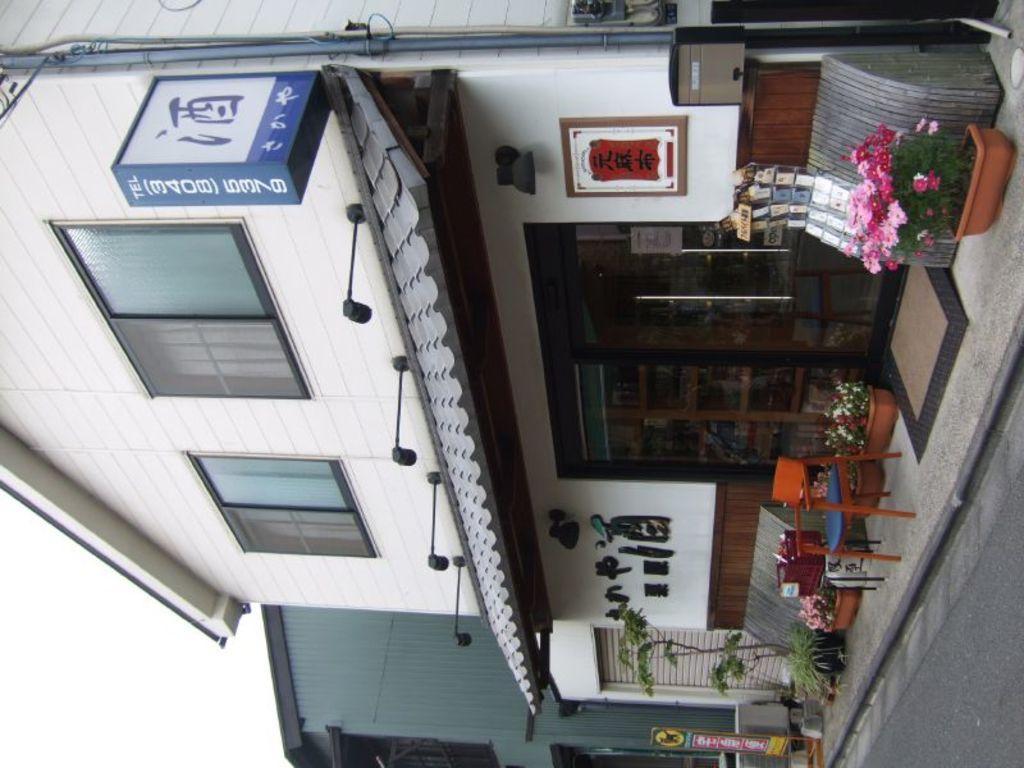Please provide a concise description of this image. In this image i can see a building and there is a window visible and there is a pipe line visible on the right side ,and there is a flower pot kept on the left side an d there is a chair kept on the middle , and there are some flower pots kept on the middle and there are some flower pots kept on the left side and there is a road visible. 